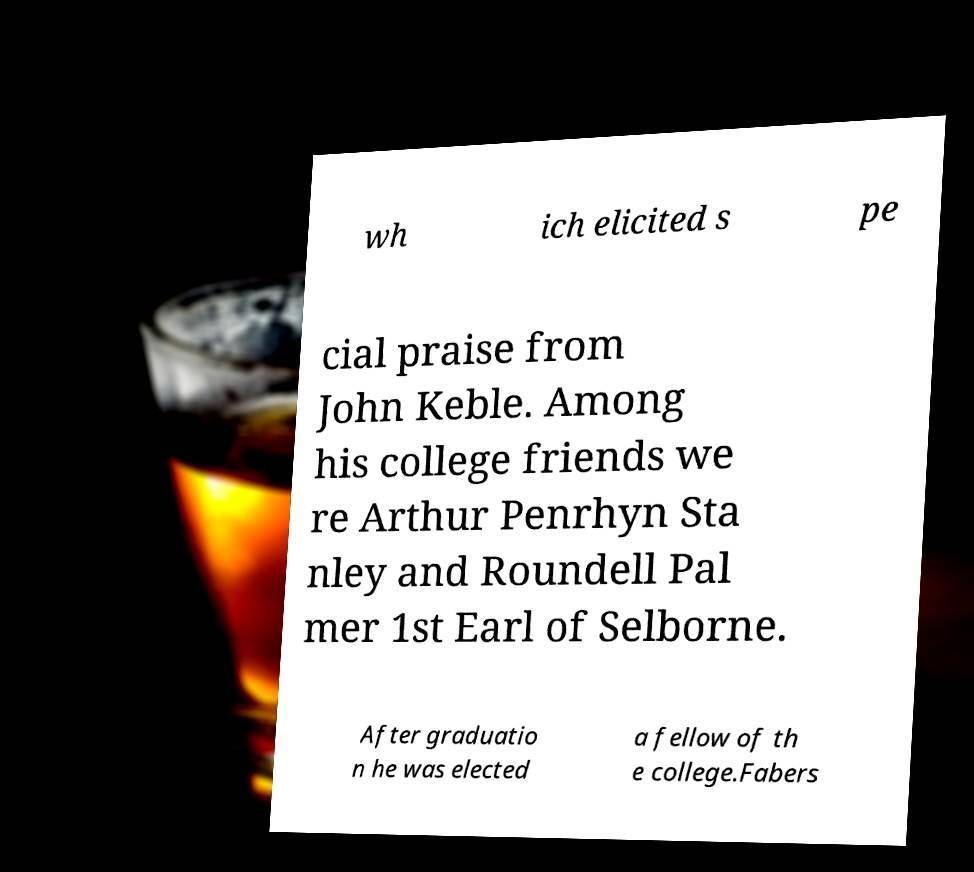Could you assist in decoding the text presented in this image and type it out clearly? wh ich elicited s pe cial praise from John Keble. Among his college friends we re Arthur Penrhyn Sta nley and Roundell Pal mer 1st Earl of Selborne. After graduatio n he was elected a fellow of th e college.Fabers 